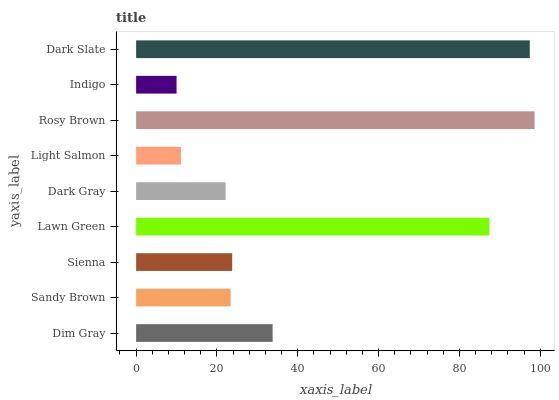Is Indigo the minimum?
Answer yes or no. Yes. Is Rosy Brown the maximum?
Answer yes or no. Yes. Is Sandy Brown the minimum?
Answer yes or no. No. Is Sandy Brown the maximum?
Answer yes or no. No. Is Dim Gray greater than Sandy Brown?
Answer yes or no. Yes. Is Sandy Brown less than Dim Gray?
Answer yes or no. Yes. Is Sandy Brown greater than Dim Gray?
Answer yes or no. No. Is Dim Gray less than Sandy Brown?
Answer yes or no. No. Is Sienna the high median?
Answer yes or no. Yes. Is Sienna the low median?
Answer yes or no. Yes. Is Dim Gray the high median?
Answer yes or no. No. Is Indigo the low median?
Answer yes or no. No. 